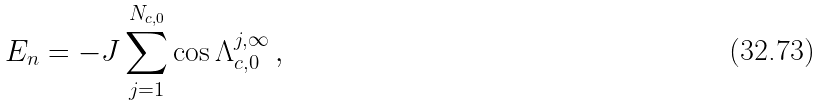Convert formula to latex. <formula><loc_0><loc_0><loc_500><loc_500>E _ { n } = - J \sum _ { j = 1 } ^ { N _ { c , 0 } } \cos \Lambda _ { c , 0 } ^ { j , \infty } \, ,</formula> 